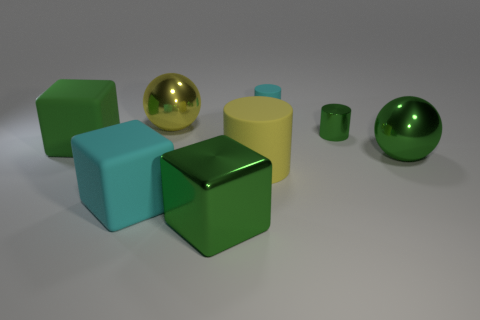The other cylinder that is the same size as the green metallic cylinder is what color?
Your answer should be very brief. Cyan. Is there a large cylinder that has the same color as the large metal cube?
Your answer should be very brief. No. Are any tiny metallic balls visible?
Give a very brief answer. No. What shape is the large shiny object on the right side of the large rubber cylinder?
Provide a succinct answer. Sphere. What number of shiny things are both behind the large cylinder and left of the big yellow rubber object?
Provide a succinct answer. 1. What number of other things are there of the same size as the cyan rubber cylinder?
Make the answer very short. 1. Is the shape of the large thing behind the small green object the same as the cyan object in front of the big green rubber object?
Offer a very short reply. No. What number of objects are either large red rubber spheres or objects left of the yellow sphere?
Make the answer very short. 2. What is the big green thing that is behind the big cyan thing and on the right side of the green matte thing made of?
Keep it short and to the point. Metal. What is the color of the tiny thing that is the same material as the big green ball?
Offer a terse response. Green. 